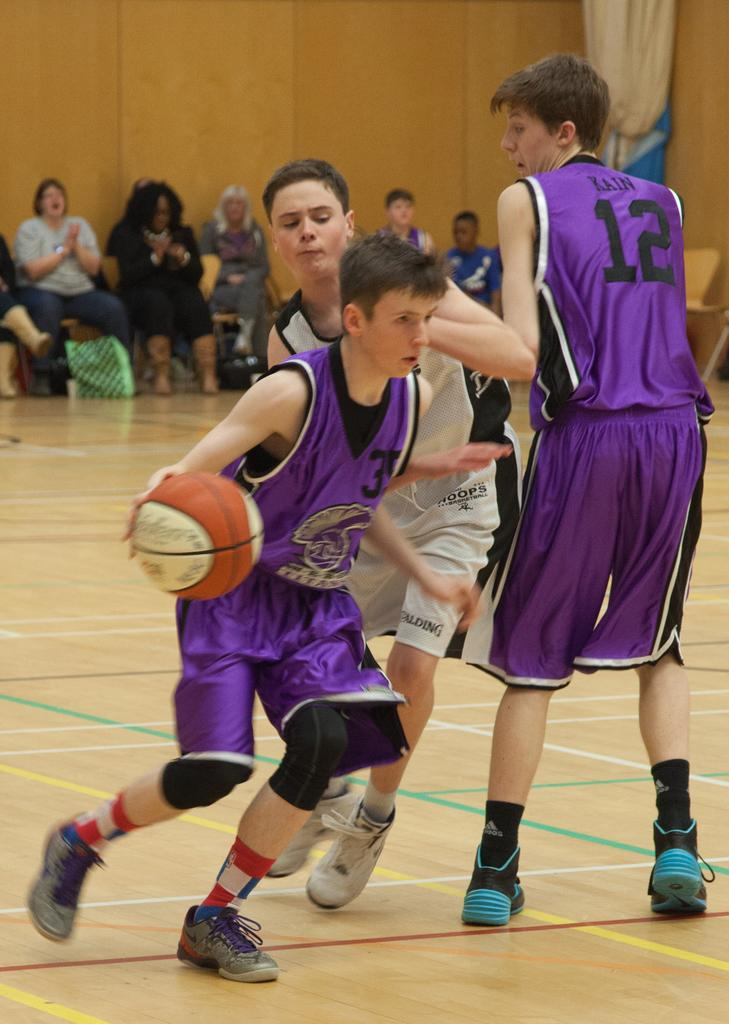What are the three persons in the image doing? The three persons in the image are playing basketball. What can be seen in the background of the image? There is a group of people sitting on chairs and a wall visible in the background. What type of steel is used to construct the basketball hoop in the image? There is no information about the material used to construct the basketball hoop in the image, so it cannot be determined. 